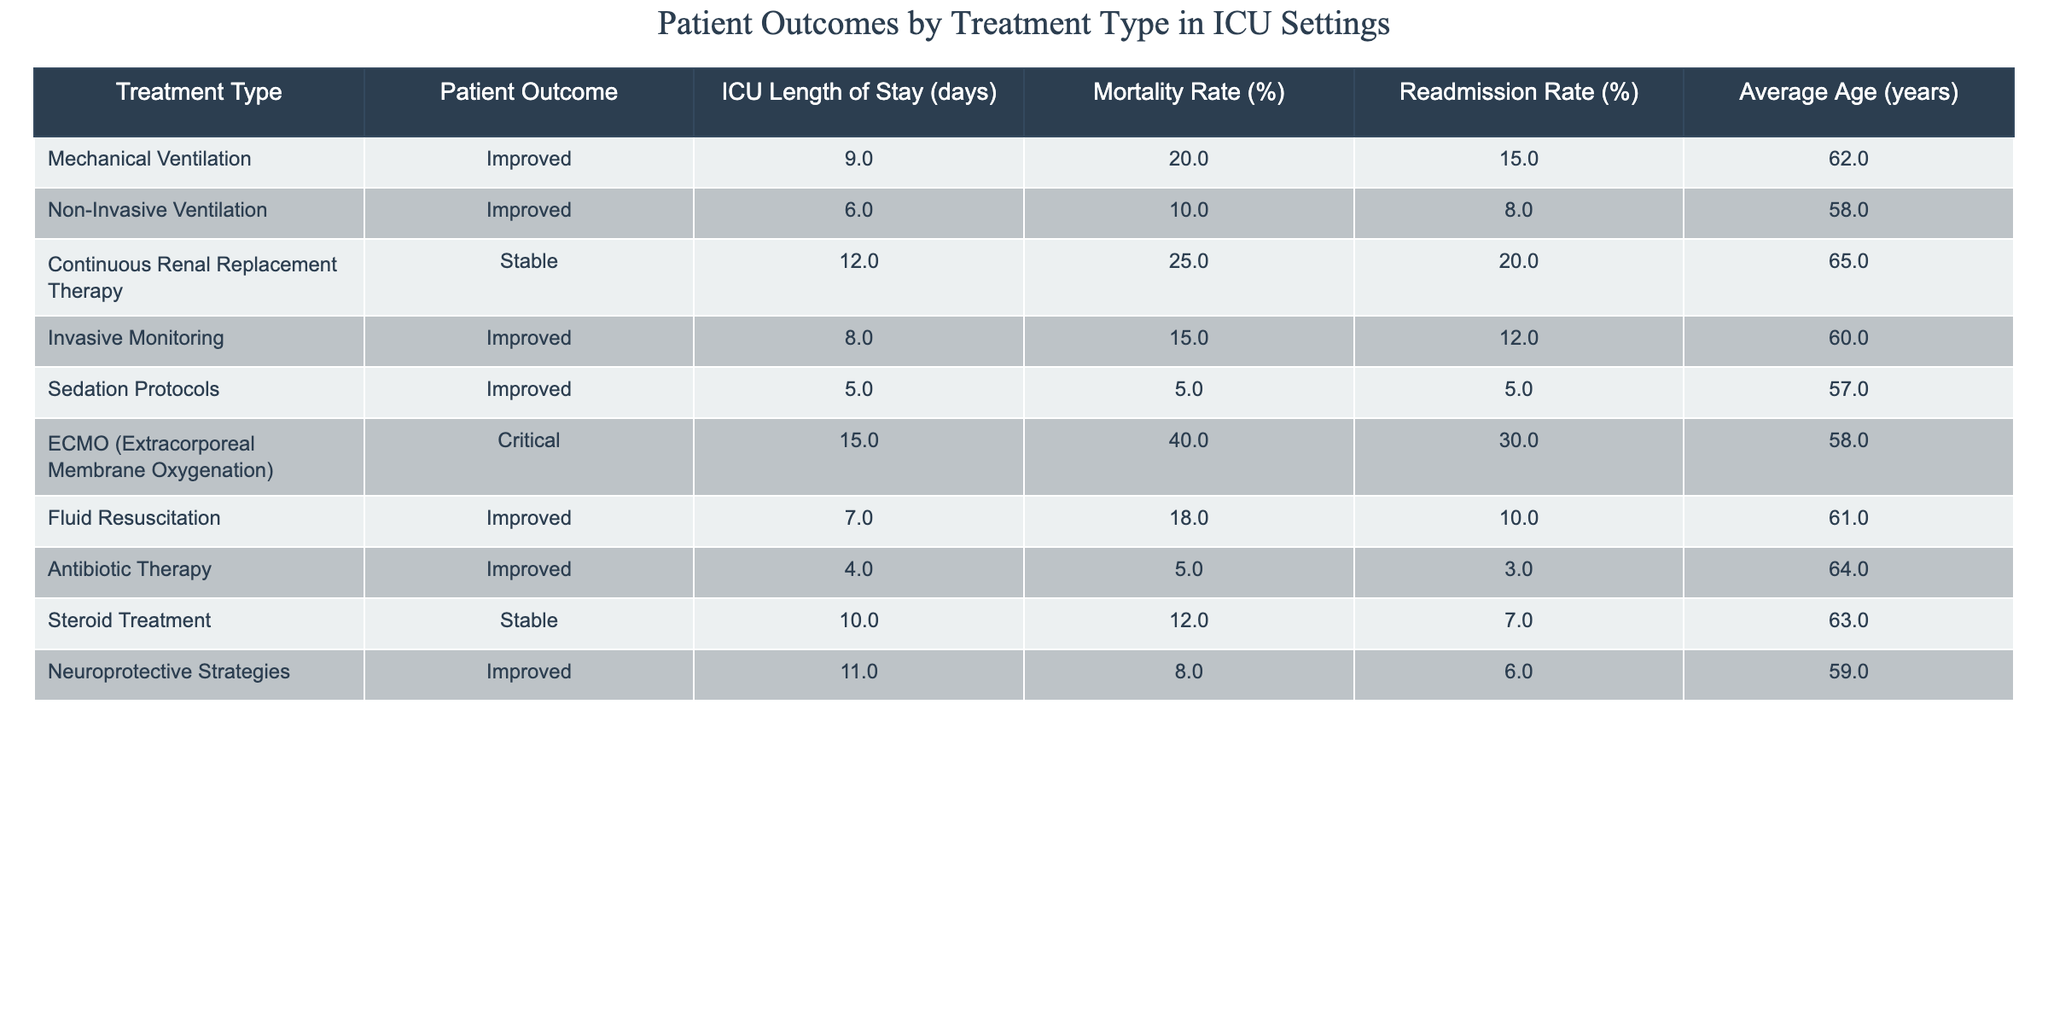What is the average ICU length of stay for patients receiving Non-Invasive Ventilation? The table lists the ICU length of stay for Non-Invasive Ventilation as 6 days. Therefore, the average ICU length of stay is 6 days.
Answer: 6 days What is the mortality rate for patients undergoing ECMO treatment? The table indicates that the mortality rate for ECMO is 40%. Hence, the mortality rate for this treatment type is 40%.
Answer: 40% Which treatment type has the lowest readmission rate? The readmission rates for each treatment type are: Mechanical Ventilation (15%), Non-Invasive Ventilation (8%), Continuous Renal Replacement Therapy (20%), Invasive Monitoring (12%), Sedation Protocols (5%), ECMO (30%), Fluid Resuscitation (10%), Antibiotic Therapy (3%), Steroid Treatment (7%), and Neuroprotective Strategies (6%). The lowest is 3% for Antibiotic Therapy.
Answer: Antibiotic Therapy How many treatment types have a mortality rate of 20% or higher? From the table, the treatments with a mortality rate of 20% or higher are Continuous Renal Replacement Therapy (25%), ECMO (40%). This totals 2 treatment types.
Answer: 2 What is the average age of patients receiving Invasive Monitoring? The table shows the average age of patients for Invasive Monitoring is 60 years. Therefore, the average age for this treatment type is 60 years.
Answer: 60 years Is the outcome for patients receiving Sedation Protocols improved? According to the data, the outcome for patients receiving Sedation Protocols is labeled as "Improved." Therefore, the statement is true.
Answer: Yes Which treatment type has the highest ICU length of stay? The ICU length of stay values are: Mechanical Ventilation (9 days), Non-Invasive Ventilation (6 days), Continuous Renal Replacement Therapy (12 days), Invasive Monitoring (8 days), Sedation Protocols (5 days), ECMO (15 days), Fluid Resuscitation (7 days), Antibiotic Therapy (4 days), Steroid Treatment (10 days), and Neuroprotective Strategies (11 days). The highest is 15 days for ECMO.
Answer: ECMO What is the difference in mortality rates between Antibiotic Therapy and Continuous Renal Replacement Therapy? For Antibiotic Therapy, the mortality rate is 5%, and for Continuous Renal Replacement Therapy, it is 25%. The difference is calculated as 25% - 5% = 20%.
Answer: 20% Which treatment type has the average age closest to 60 years? The average ages are: Mechanical Ventilation (62), Non-Invasive Ventilation (58), Continuous Renal Replacement Therapy (65), Invasive Monitoring (60), Sedation Protocols (57), ECMO (58), Fluid Resuscitation (61), Antibiotic Therapy (64), Steroid Treatment (63), and Neuroprotective Strategies (59). Invasive Monitoring at 60 years is exactly 60.
Answer: Invasive Monitoring How do the mortality rates correlate between Mechanical Ventilation and Non-Invasive Ventilation? The mortality rate for Mechanical Ventilation is 20% and for Non-Invasive Ventilation it is 10%. Both treatments are distinct; however, Non-Invasive Ventilation has a lower mortality rate. Therefore, the correlation shows both are lower, but Non-Invasive has a better outcome.
Answer: Non-Invasive Ventilation has a lower mortality rate 